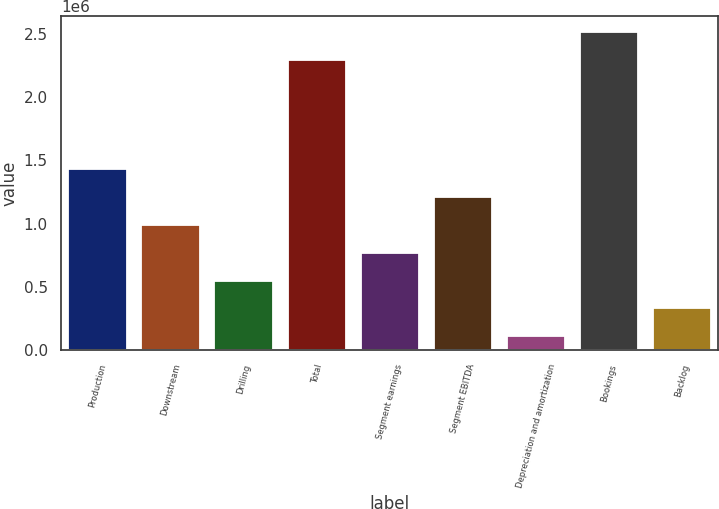Convert chart to OTSL. <chart><loc_0><loc_0><loc_500><loc_500><bar_chart><fcel>Production<fcel>Downstream<fcel>Drilling<fcel>Total<fcel>Segment earnings<fcel>Segment EBITDA<fcel>Depreciation and amortization<fcel>Bookings<fcel>Backlog<nl><fcel>1.43082e+06<fcel>989659<fcel>548502<fcel>2.29645e+06<fcel>769080<fcel>1.21024e+06<fcel>107344<fcel>2.51703e+06<fcel>327923<nl></chart> 